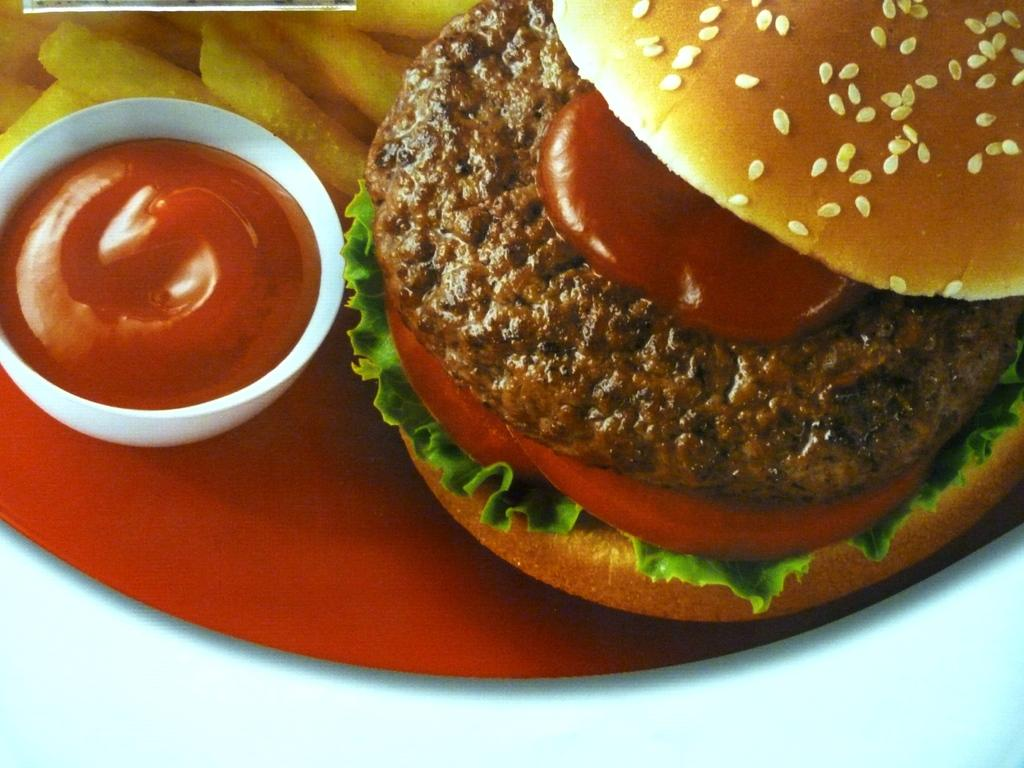What type of food is the main subject in the image? There is a burger in the image. What side dish accompanies the burger? There are french fries in the image. What color is the plate that holds the burger and french fries? The plate is red. What is the container for the sauce in the image? The sauce is in a cup in the image. Where is the plate with the burger and french fries located? The plate is placed on a table. What type of drum is visible in the image? There is no drum present in the image. Are there any socks visible in the image? There are no socks present in the image. 